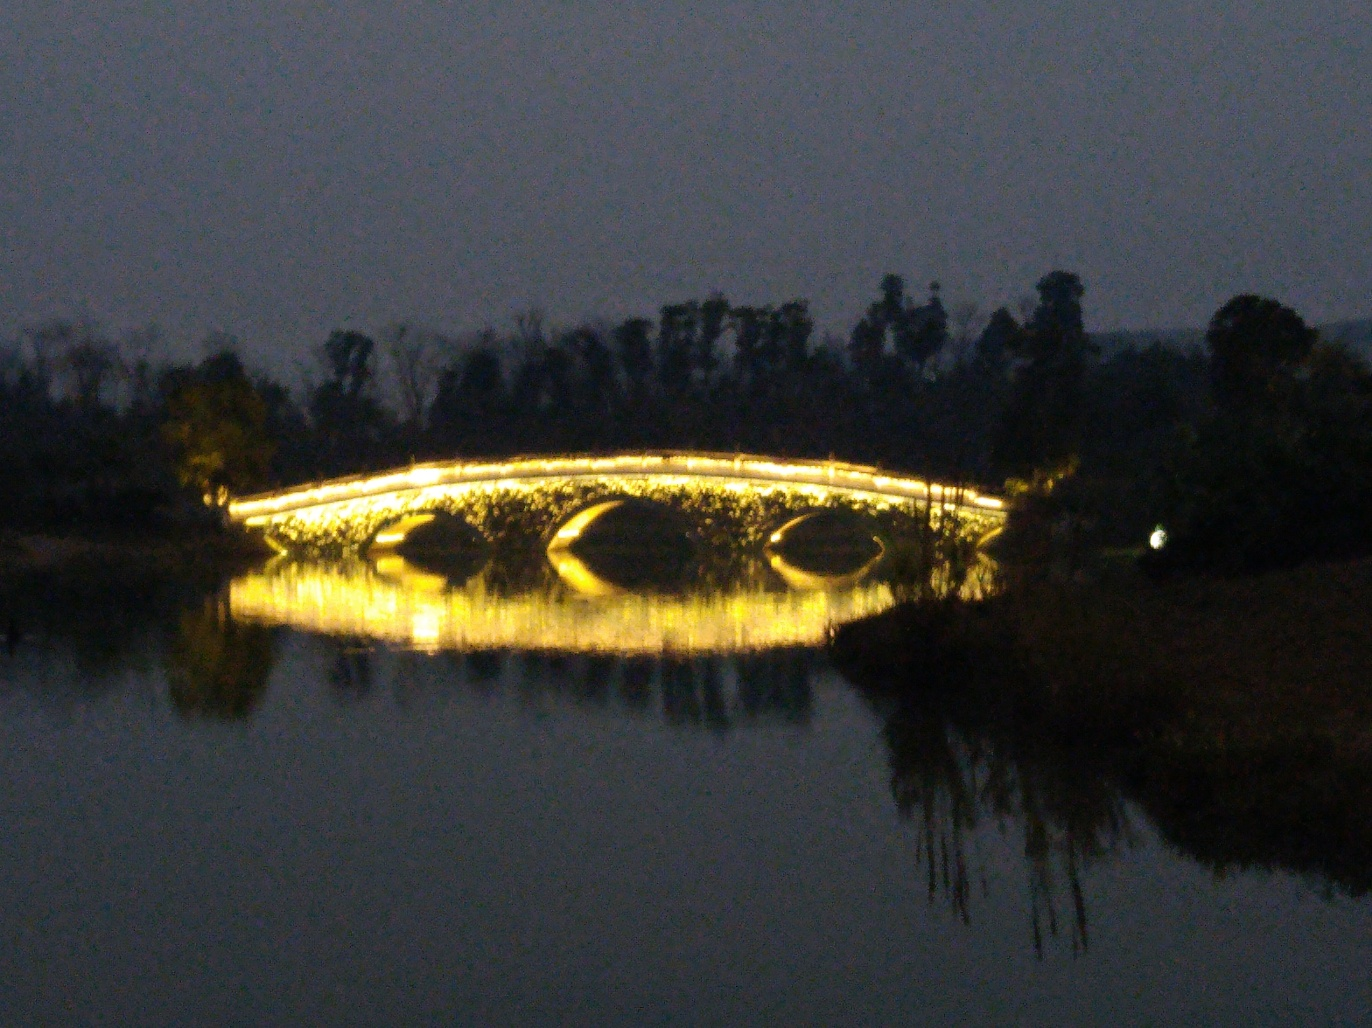Can you tell me about the architecture of the bridge and its significance? The bridge shown in the image features a classic arched design, which is not only aesthetically pleasing but also structurally efficient for distributing weight. The lighting accentuates its form, potentially indicating it is a local landmark or place of interest, possibly used for evening strolls or as a scenic point in the area. 